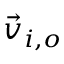Convert formula to latex. <formula><loc_0><loc_0><loc_500><loc_500>\vec { v } _ { i , o }</formula> 